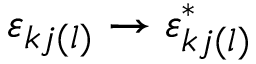Convert formula to latex. <formula><loc_0><loc_0><loc_500><loc_500>\varepsilon _ { k j ( l ) } \to \varepsilon _ { k j ( l ) } ^ { * }</formula> 